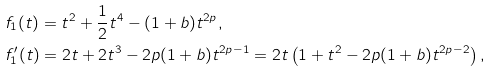<formula> <loc_0><loc_0><loc_500><loc_500>& f _ { 1 } ( t ) = t ^ { 2 } + \frac { 1 } { 2 } t ^ { 4 } - ( 1 + b ) t ^ { 2 p } , \\ & f _ { 1 } ^ { \prime } ( t ) = 2 t + 2 t ^ { 3 } - 2 p ( 1 + b ) t ^ { 2 p - 1 } = 2 t \left ( 1 + t ^ { 2 } - 2 p ( 1 + b ) t ^ { 2 p - 2 } \right ) ,</formula> 